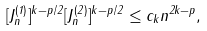Convert formula to latex. <formula><loc_0><loc_0><loc_500><loc_500>[ J _ { n } ^ { ( 1 ) } ] ^ { k - p / 2 } [ J _ { n } ^ { ( 2 ) } ] ^ { k - p / 2 } \leq c _ { k } n ^ { 2 k - p } ,</formula> 